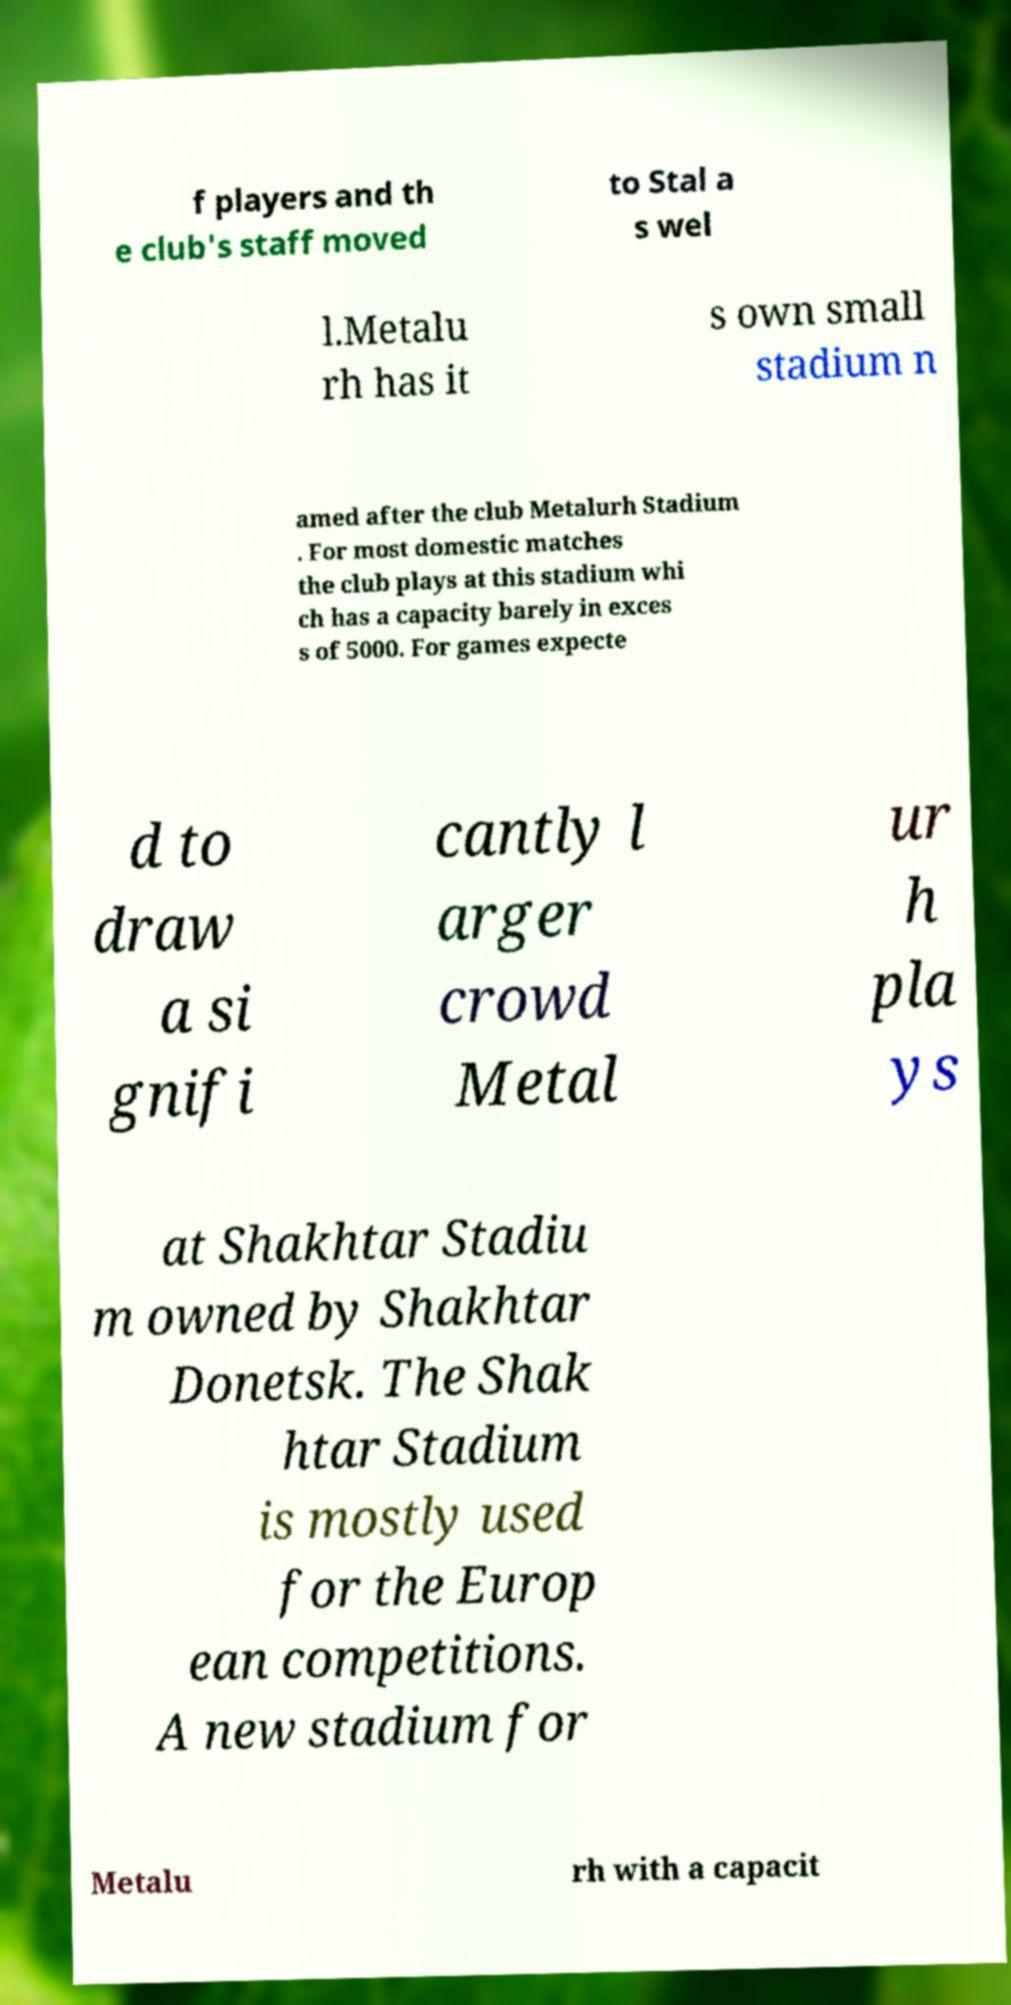Can you accurately transcribe the text from the provided image for me? f players and th e club's staff moved to Stal a s wel l.Metalu rh has it s own small stadium n amed after the club Metalurh Stadium . For most domestic matches the club plays at this stadium whi ch has a capacity barely in exces s of 5000. For games expecte d to draw a si gnifi cantly l arger crowd Metal ur h pla ys at Shakhtar Stadiu m owned by Shakhtar Donetsk. The Shak htar Stadium is mostly used for the Europ ean competitions. A new stadium for Metalu rh with a capacit 